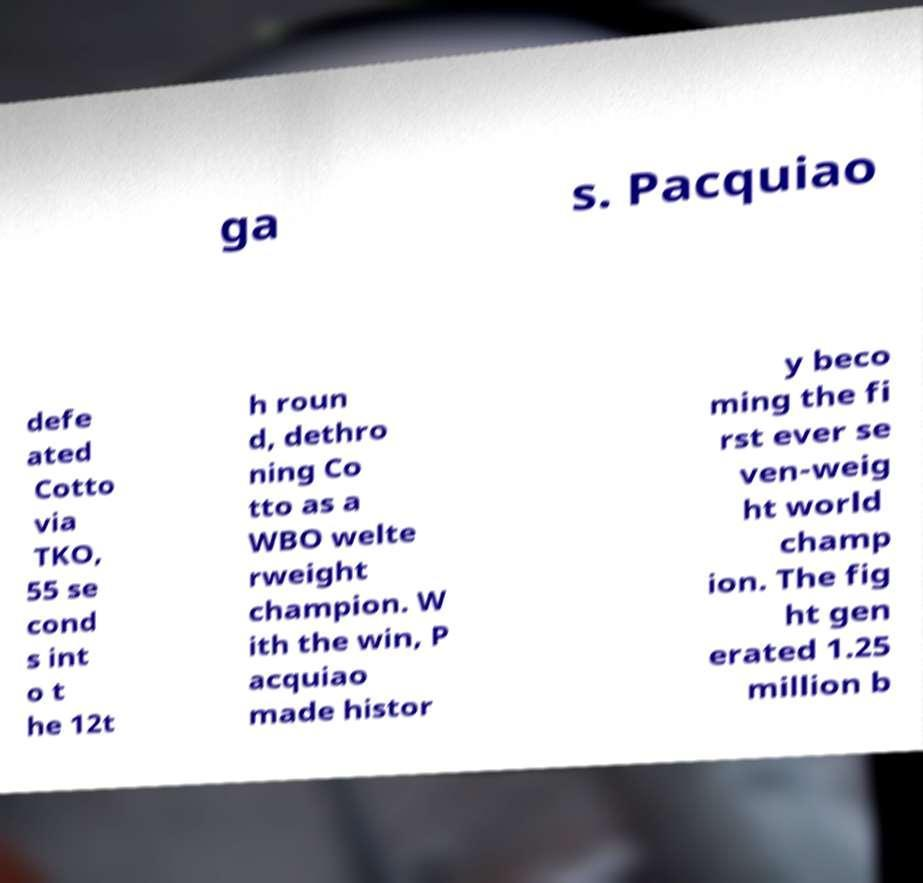What messages or text are displayed in this image? I need them in a readable, typed format. ga s. Pacquiao defe ated Cotto via TKO, 55 se cond s int o t he 12t h roun d, dethro ning Co tto as a WBO welte rweight champion. W ith the win, P acquiao made histor y beco ming the fi rst ever se ven-weig ht world champ ion. The fig ht gen erated 1.25 million b 